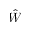Convert formula to latex. <formula><loc_0><loc_0><loc_500><loc_500>\hat { W }</formula> 